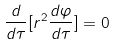<formula> <loc_0><loc_0><loc_500><loc_500>\frac { d } { d \tau } [ r ^ { 2 } \frac { d \varphi } { d \tau } ] = 0</formula> 